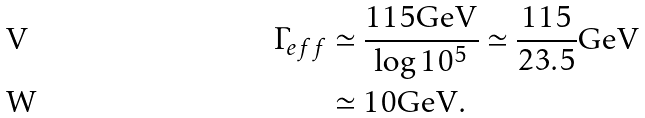<formula> <loc_0><loc_0><loc_500><loc_500>\Gamma _ { e f f } & \simeq \frac { 1 1 5 \text {GeV} } { \log 1 0 ^ { 5 } } \simeq \frac { 1 1 5 } { 2 3 . 5 } \text {GeV} \\ & \simeq 1 0 \text {GeV} .</formula> 